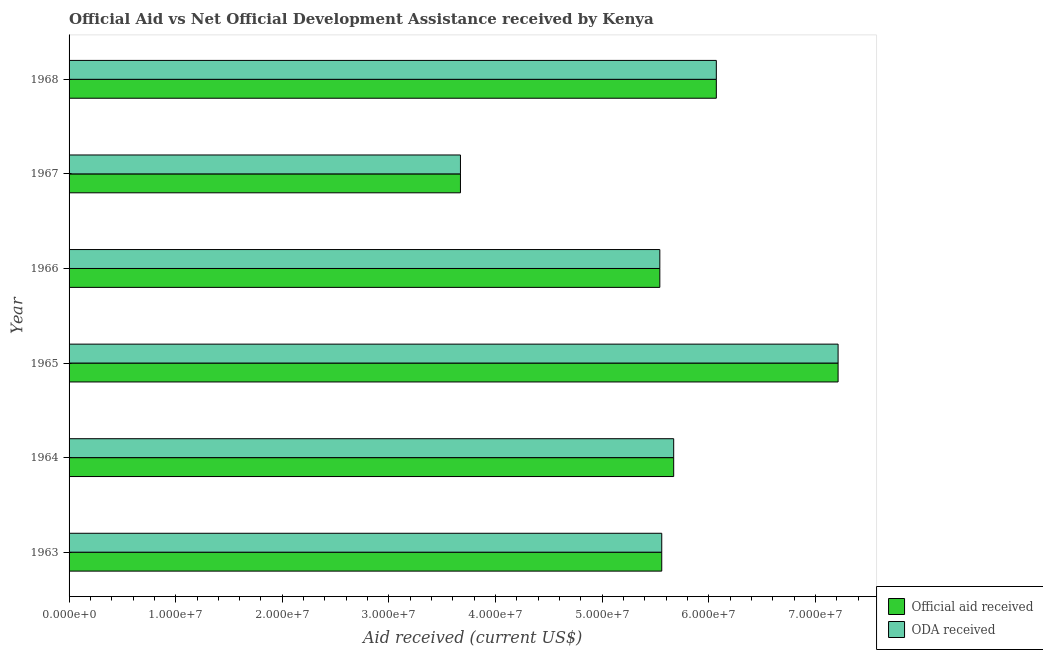How many different coloured bars are there?
Give a very brief answer. 2. What is the label of the 6th group of bars from the top?
Make the answer very short. 1963. What is the official aid received in 1968?
Provide a succinct answer. 6.07e+07. Across all years, what is the maximum oda received?
Your answer should be very brief. 7.21e+07. Across all years, what is the minimum oda received?
Offer a terse response. 3.67e+07. In which year was the official aid received maximum?
Offer a terse response. 1965. In which year was the official aid received minimum?
Your answer should be compact. 1967. What is the total oda received in the graph?
Ensure brevity in your answer.  3.37e+08. What is the difference between the oda received in 1964 and that in 1965?
Give a very brief answer. -1.54e+07. What is the difference between the oda received in 1967 and the official aid received in 1964?
Offer a very short reply. -2.00e+07. What is the average oda received per year?
Offer a very short reply. 5.62e+07. In how many years, is the oda received greater than 4000000 US$?
Your answer should be compact. 6. What is the ratio of the official aid received in 1964 to that in 1967?
Your answer should be very brief. 1.54. What is the difference between the highest and the second highest official aid received?
Offer a terse response. 1.14e+07. What is the difference between the highest and the lowest official aid received?
Offer a terse response. 3.54e+07. What does the 2nd bar from the top in 1964 represents?
Provide a short and direct response. Official aid received. What does the 1st bar from the bottom in 1964 represents?
Provide a short and direct response. Official aid received. How many bars are there?
Your response must be concise. 12. How many years are there in the graph?
Ensure brevity in your answer.  6. Are the values on the major ticks of X-axis written in scientific E-notation?
Make the answer very short. Yes. Does the graph contain any zero values?
Your answer should be very brief. No. How are the legend labels stacked?
Offer a very short reply. Vertical. What is the title of the graph?
Offer a very short reply. Official Aid vs Net Official Development Assistance received by Kenya . What is the label or title of the X-axis?
Provide a succinct answer. Aid received (current US$). What is the Aid received (current US$) in Official aid received in 1963?
Ensure brevity in your answer.  5.56e+07. What is the Aid received (current US$) in ODA received in 1963?
Ensure brevity in your answer.  5.56e+07. What is the Aid received (current US$) of Official aid received in 1964?
Your answer should be very brief. 5.67e+07. What is the Aid received (current US$) in ODA received in 1964?
Provide a short and direct response. 5.67e+07. What is the Aid received (current US$) in Official aid received in 1965?
Your answer should be very brief. 7.21e+07. What is the Aid received (current US$) in ODA received in 1965?
Provide a succinct answer. 7.21e+07. What is the Aid received (current US$) of Official aid received in 1966?
Provide a short and direct response. 5.54e+07. What is the Aid received (current US$) of ODA received in 1966?
Keep it short and to the point. 5.54e+07. What is the Aid received (current US$) of Official aid received in 1967?
Keep it short and to the point. 3.67e+07. What is the Aid received (current US$) of ODA received in 1967?
Your answer should be very brief. 3.67e+07. What is the Aid received (current US$) in Official aid received in 1968?
Keep it short and to the point. 6.07e+07. What is the Aid received (current US$) in ODA received in 1968?
Provide a short and direct response. 6.07e+07. Across all years, what is the maximum Aid received (current US$) in Official aid received?
Ensure brevity in your answer.  7.21e+07. Across all years, what is the maximum Aid received (current US$) in ODA received?
Your answer should be compact. 7.21e+07. Across all years, what is the minimum Aid received (current US$) in Official aid received?
Your answer should be compact. 3.67e+07. Across all years, what is the minimum Aid received (current US$) in ODA received?
Keep it short and to the point. 3.67e+07. What is the total Aid received (current US$) of Official aid received in the graph?
Make the answer very short. 3.37e+08. What is the total Aid received (current US$) in ODA received in the graph?
Your answer should be compact. 3.37e+08. What is the difference between the Aid received (current US$) in Official aid received in 1963 and that in 1964?
Offer a very short reply. -1.12e+06. What is the difference between the Aid received (current US$) of ODA received in 1963 and that in 1964?
Ensure brevity in your answer.  -1.12e+06. What is the difference between the Aid received (current US$) of Official aid received in 1963 and that in 1965?
Your answer should be compact. -1.65e+07. What is the difference between the Aid received (current US$) in ODA received in 1963 and that in 1965?
Provide a succinct answer. -1.65e+07. What is the difference between the Aid received (current US$) of Official aid received in 1963 and that in 1966?
Your answer should be very brief. 1.80e+05. What is the difference between the Aid received (current US$) of ODA received in 1963 and that in 1966?
Ensure brevity in your answer.  1.80e+05. What is the difference between the Aid received (current US$) in Official aid received in 1963 and that in 1967?
Provide a succinct answer. 1.89e+07. What is the difference between the Aid received (current US$) of ODA received in 1963 and that in 1967?
Your answer should be compact. 1.89e+07. What is the difference between the Aid received (current US$) in Official aid received in 1963 and that in 1968?
Offer a terse response. -5.12e+06. What is the difference between the Aid received (current US$) in ODA received in 1963 and that in 1968?
Keep it short and to the point. -5.12e+06. What is the difference between the Aid received (current US$) in Official aid received in 1964 and that in 1965?
Your response must be concise. -1.54e+07. What is the difference between the Aid received (current US$) in ODA received in 1964 and that in 1965?
Your response must be concise. -1.54e+07. What is the difference between the Aid received (current US$) in Official aid received in 1964 and that in 1966?
Your answer should be compact. 1.30e+06. What is the difference between the Aid received (current US$) of ODA received in 1964 and that in 1966?
Offer a terse response. 1.30e+06. What is the difference between the Aid received (current US$) of Official aid received in 1964 and that in 1967?
Your answer should be very brief. 2.00e+07. What is the difference between the Aid received (current US$) of ODA received in 1964 and that in 1967?
Keep it short and to the point. 2.00e+07. What is the difference between the Aid received (current US$) in Official aid received in 1964 and that in 1968?
Offer a terse response. -4.00e+06. What is the difference between the Aid received (current US$) in ODA received in 1964 and that in 1968?
Offer a very short reply. -4.00e+06. What is the difference between the Aid received (current US$) of Official aid received in 1965 and that in 1966?
Make the answer very short. 1.67e+07. What is the difference between the Aid received (current US$) in ODA received in 1965 and that in 1966?
Ensure brevity in your answer.  1.67e+07. What is the difference between the Aid received (current US$) in Official aid received in 1965 and that in 1967?
Ensure brevity in your answer.  3.54e+07. What is the difference between the Aid received (current US$) of ODA received in 1965 and that in 1967?
Provide a short and direct response. 3.54e+07. What is the difference between the Aid received (current US$) in Official aid received in 1965 and that in 1968?
Give a very brief answer. 1.14e+07. What is the difference between the Aid received (current US$) in ODA received in 1965 and that in 1968?
Offer a very short reply. 1.14e+07. What is the difference between the Aid received (current US$) of Official aid received in 1966 and that in 1967?
Keep it short and to the point. 1.87e+07. What is the difference between the Aid received (current US$) in ODA received in 1966 and that in 1967?
Keep it short and to the point. 1.87e+07. What is the difference between the Aid received (current US$) of Official aid received in 1966 and that in 1968?
Give a very brief answer. -5.30e+06. What is the difference between the Aid received (current US$) of ODA received in 1966 and that in 1968?
Offer a terse response. -5.30e+06. What is the difference between the Aid received (current US$) of Official aid received in 1967 and that in 1968?
Give a very brief answer. -2.40e+07. What is the difference between the Aid received (current US$) in ODA received in 1967 and that in 1968?
Give a very brief answer. -2.40e+07. What is the difference between the Aid received (current US$) in Official aid received in 1963 and the Aid received (current US$) in ODA received in 1964?
Provide a short and direct response. -1.12e+06. What is the difference between the Aid received (current US$) in Official aid received in 1963 and the Aid received (current US$) in ODA received in 1965?
Provide a succinct answer. -1.65e+07. What is the difference between the Aid received (current US$) in Official aid received in 1963 and the Aid received (current US$) in ODA received in 1967?
Provide a short and direct response. 1.89e+07. What is the difference between the Aid received (current US$) in Official aid received in 1963 and the Aid received (current US$) in ODA received in 1968?
Offer a terse response. -5.12e+06. What is the difference between the Aid received (current US$) of Official aid received in 1964 and the Aid received (current US$) of ODA received in 1965?
Your answer should be compact. -1.54e+07. What is the difference between the Aid received (current US$) of Official aid received in 1964 and the Aid received (current US$) of ODA received in 1966?
Your answer should be very brief. 1.30e+06. What is the difference between the Aid received (current US$) of Official aid received in 1964 and the Aid received (current US$) of ODA received in 1968?
Provide a short and direct response. -4.00e+06. What is the difference between the Aid received (current US$) of Official aid received in 1965 and the Aid received (current US$) of ODA received in 1966?
Offer a very short reply. 1.67e+07. What is the difference between the Aid received (current US$) in Official aid received in 1965 and the Aid received (current US$) in ODA received in 1967?
Offer a terse response. 3.54e+07. What is the difference between the Aid received (current US$) in Official aid received in 1965 and the Aid received (current US$) in ODA received in 1968?
Offer a very short reply. 1.14e+07. What is the difference between the Aid received (current US$) in Official aid received in 1966 and the Aid received (current US$) in ODA received in 1967?
Give a very brief answer. 1.87e+07. What is the difference between the Aid received (current US$) of Official aid received in 1966 and the Aid received (current US$) of ODA received in 1968?
Provide a short and direct response. -5.30e+06. What is the difference between the Aid received (current US$) of Official aid received in 1967 and the Aid received (current US$) of ODA received in 1968?
Your response must be concise. -2.40e+07. What is the average Aid received (current US$) in Official aid received per year?
Provide a succinct answer. 5.62e+07. What is the average Aid received (current US$) in ODA received per year?
Your answer should be compact. 5.62e+07. In the year 1964, what is the difference between the Aid received (current US$) in Official aid received and Aid received (current US$) in ODA received?
Provide a short and direct response. 0. In the year 1967, what is the difference between the Aid received (current US$) in Official aid received and Aid received (current US$) in ODA received?
Offer a very short reply. 0. In the year 1968, what is the difference between the Aid received (current US$) in Official aid received and Aid received (current US$) in ODA received?
Provide a short and direct response. 0. What is the ratio of the Aid received (current US$) of Official aid received in 1963 to that in 1964?
Provide a short and direct response. 0.98. What is the ratio of the Aid received (current US$) of ODA received in 1963 to that in 1964?
Keep it short and to the point. 0.98. What is the ratio of the Aid received (current US$) in Official aid received in 1963 to that in 1965?
Provide a succinct answer. 0.77. What is the ratio of the Aid received (current US$) in ODA received in 1963 to that in 1965?
Keep it short and to the point. 0.77. What is the ratio of the Aid received (current US$) of Official aid received in 1963 to that in 1967?
Give a very brief answer. 1.51. What is the ratio of the Aid received (current US$) of ODA received in 1963 to that in 1967?
Offer a terse response. 1.51. What is the ratio of the Aid received (current US$) in Official aid received in 1963 to that in 1968?
Provide a succinct answer. 0.92. What is the ratio of the Aid received (current US$) in ODA received in 1963 to that in 1968?
Your answer should be compact. 0.92. What is the ratio of the Aid received (current US$) in Official aid received in 1964 to that in 1965?
Keep it short and to the point. 0.79. What is the ratio of the Aid received (current US$) in ODA received in 1964 to that in 1965?
Your answer should be compact. 0.79. What is the ratio of the Aid received (current US$) of Official aid received in 1964 to that in 1966?
Provide a succinct answer. 1.02. What is the ratio of the Aid received (current US$) in ODA received in 1964 to that in 1966?
Ensure brevity in your answer.  1.02. What is the ratio of the Aid received (current US$) of Official aid received in 1964 to that in 1967?
Keep it short and to the point. 1.54. What is the ratio of the Aid received (current US$) of ODA received in 1964 to that in 1967?
Make the answer very short. 1.54. What is the ratio of the Aid received (current US$) of Official aid received in 1964 to that in 1968?
Your answer should be very brief. 0.93. What is the ratio of the Aid received (current US$) in ODA received in 1964 to that in 1968?
Give a very brief answer. 0.93. What is the ratio of the Aid received (current US$) of Official aid received in 1965 to that in 1966?
Your answer should be very brief. 1.3. What is the ratio of the Aid received (current US$) of ODA received in 1965 to that in 1966?
Give a very brief answer. 1.3. What is the ratio of the Aid received (current US$) of Official aid received in 1965 to that in 1967?
Your answer should be very brief. 1.96. What is the ratio of the Aid received (current US$) in ODA received in 1965 to that in 1967?
Your answer should be very brief. 1.96. What is the ratio of the Aid received (current US$) of Official aid received in 1965 to that in 1968?
Offer a very short reply. 1.19. What is the ratio of the Aid received (current US$) in ODA received in 1965 to that in 1968?
Offer a terse response. 1.19. What is the ratio of the Aid received (current US$) of Official aid received in 1966 to that in 1967?
Offer a very short reply. 1.51. What is the ratio of the Aid received (current US$) of ODA received in 1966 to that in 1967?
Ensure brevity in your answer.  1.51. What is the ratio of the Aid received (current US$) in Official aid received in 1966 to that in 1968?
Provide a short and direct response. 0.91. What is the ratio of the Aid received (current US$) of ODA received in 1966 to that in 1968?
Offer a terse response. 0.91. What is the ratio of the Aid received (current US$) in Official aid received in 1967 to that in 1968?
Provide a short and direct response. 0.6. What is the ratio of the Aid received (current US$) in ODA received in 1967 to that in 1968?
Make the answer very short. 0.6. What is the difference between the highest and the second highest Aid received (current US$) of Official aid received?
Provide a short and direct response. 1.14e+07. What is the difference between the highest and the second highest Aid received (current US$) of ODA received?
Keep it short and to the point. 1.14e+07. What is the difference between the highest and the lowest Aid received (current US$) in Official aid received?
Your answer should be very brief. 3.54e+07. What is the difference between the highest and the lowest Aid received (current US$) in ODA received?
Offer a terse response. 3.54e+07. 